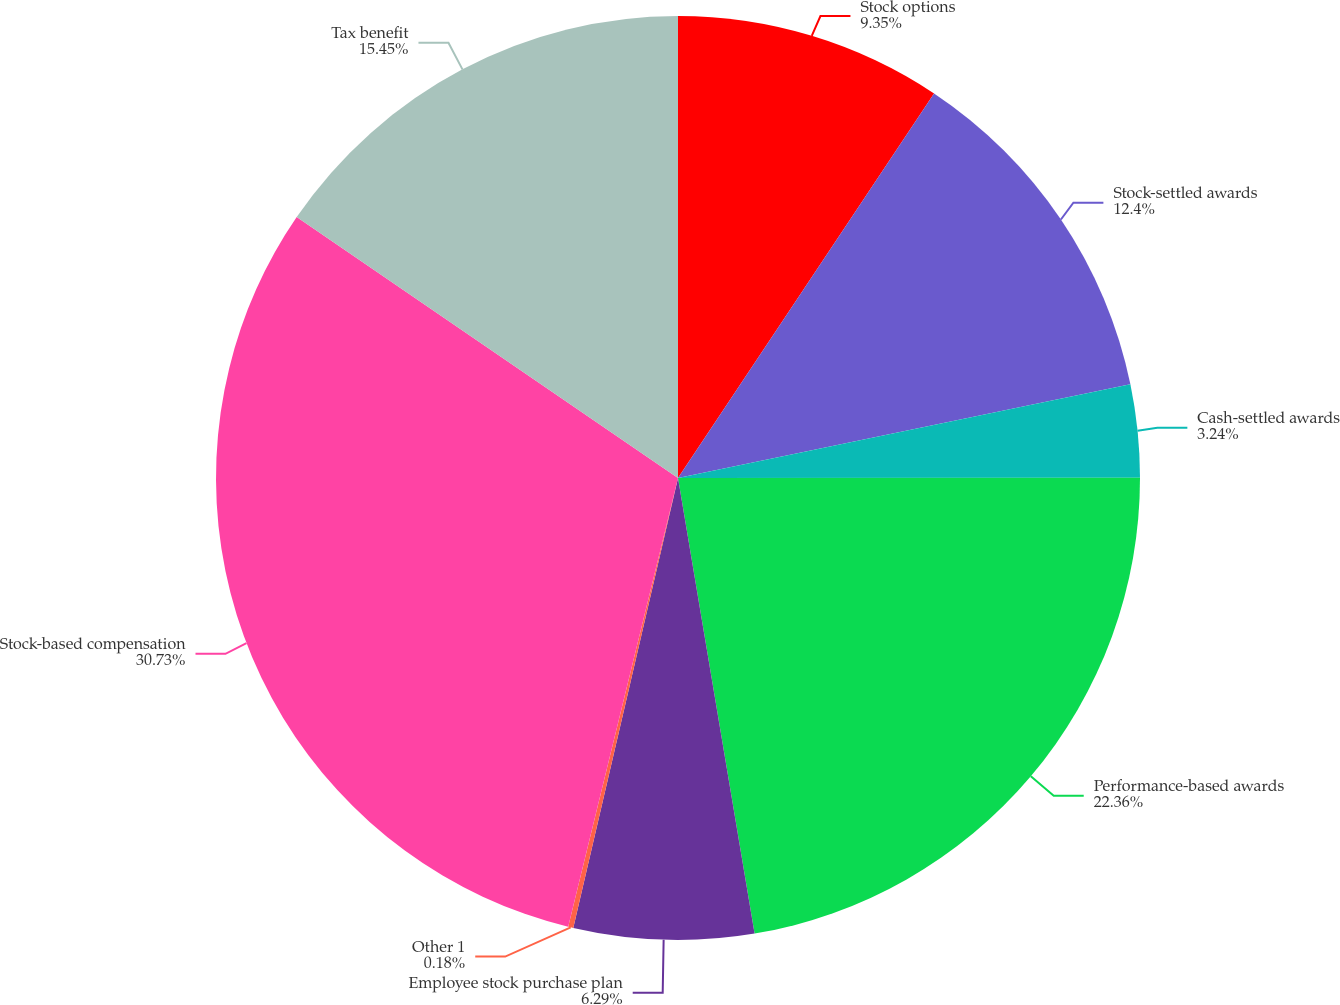Convert chart. <chart><loc_0><loc_0><loc_500><loc_500><pie_chart><fcel>Stock options<fcel>Stock-settled awards<fcel>Cash-settled awards<fcel>Performance-based awards<fcel>Employee stock purchase plan<fcel>Other 1<fcel>Stock-based compensation<fcel>Tax benefit<nl><fcel>9.35%<fcel>12.4%<fcel>3.24%<fcel>22.36%<fcel>6.29%<fcel>0.18%<fcel>30.73%<fcel>15.45%<nl></chart> 